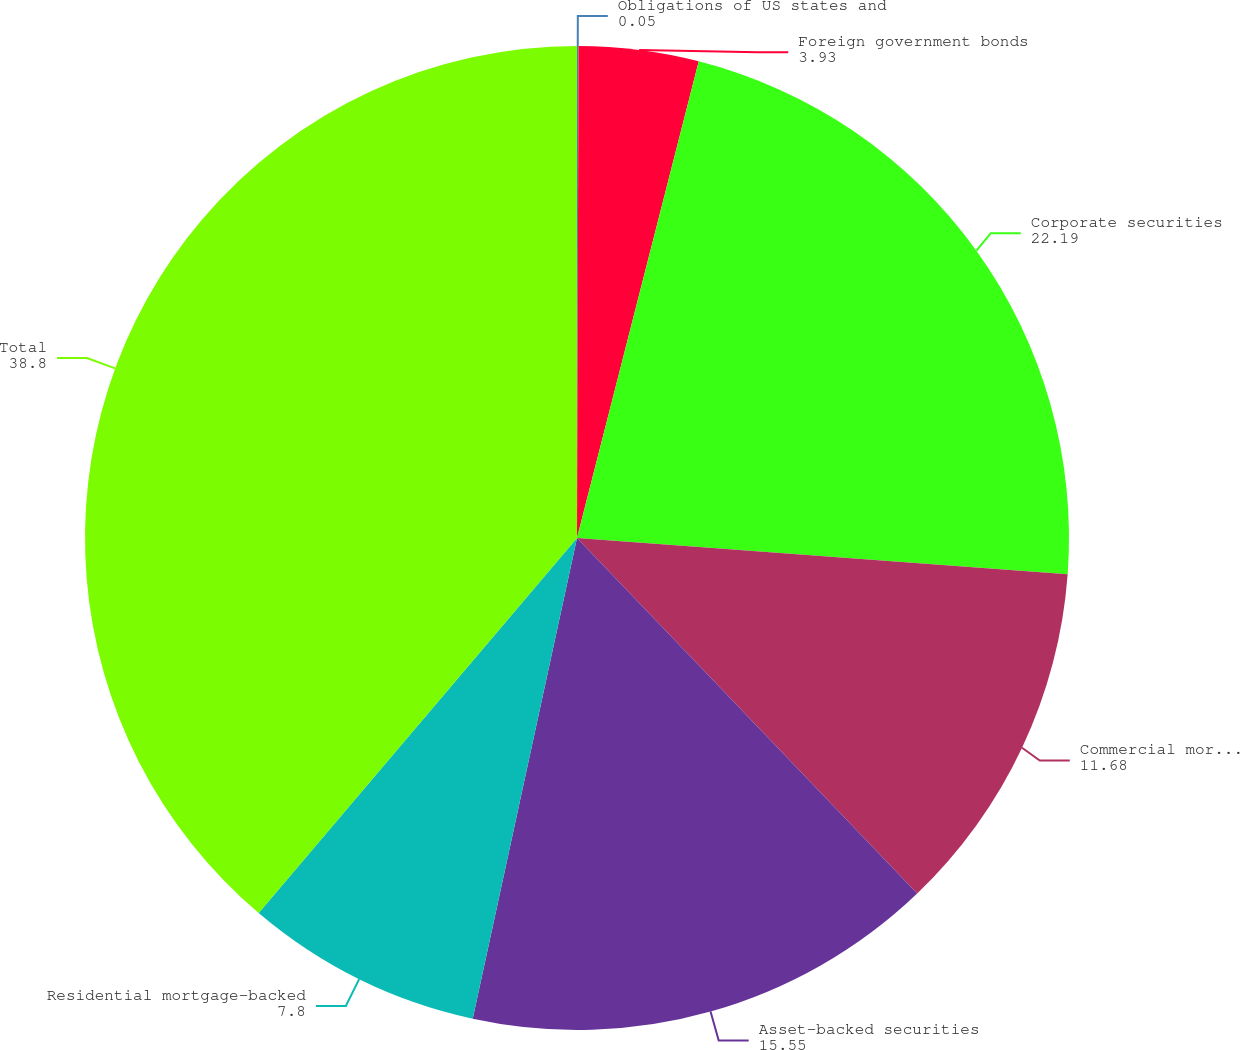Convert chart to OTSL. <chart><loc_0><loc_0><loc_500><loc_500><pie_chart><fcel>Obligations of US states and<fcel>Foreign government bonds<fcel>Corporate securities<fcel>Commercial mortgage-backed<fcel>Asset-backed securities<fcel>Residential mortgage-backed<fcel>Total<nl><fcel>0.05%<fcel>3.93%<fcel>22.19%<fcel>11.68%<fcel>15.55%<fcel>7.8%<fcel>38.8%<nl></chart> 